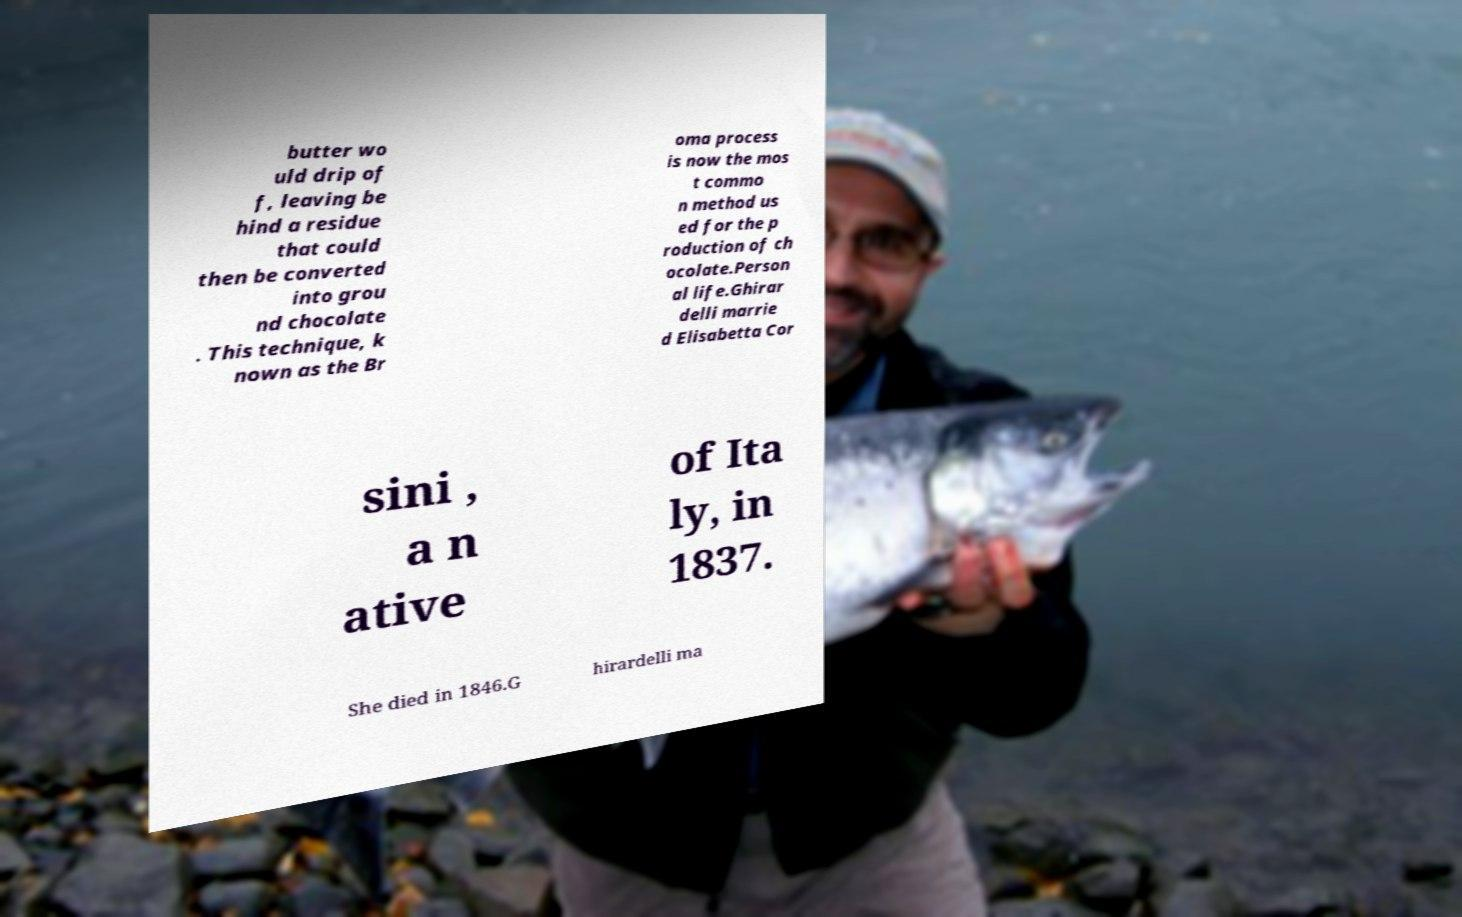I need the written content from this picture converted into text. Can you do that? butter wo uld drip of f, leaving be hind a residue that could then be converted into grou nd chocolate . This technique, k nown as the Br oma process is now the mos t commo n method us ed for the p roduction of ch ocolate.Person al life.Ghirar delli marrie d Elisabetta Cor sini , a n ative of Ita ly, in 1837. She died in 1846.G hirardelli ma 